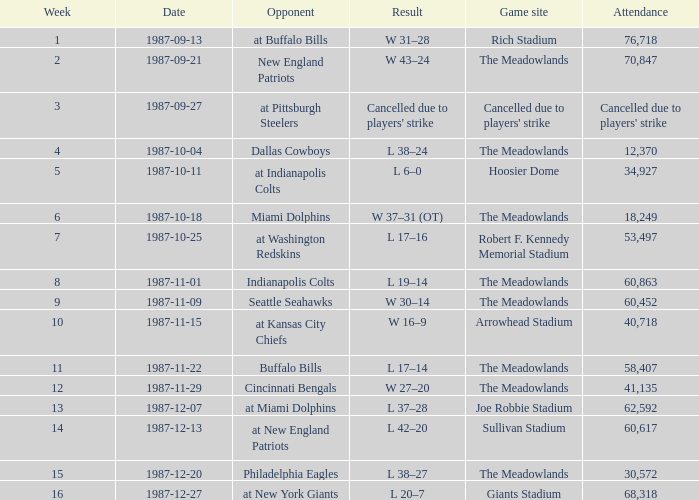Who were the jets' opponents in their game after week 15? At new york giants. 